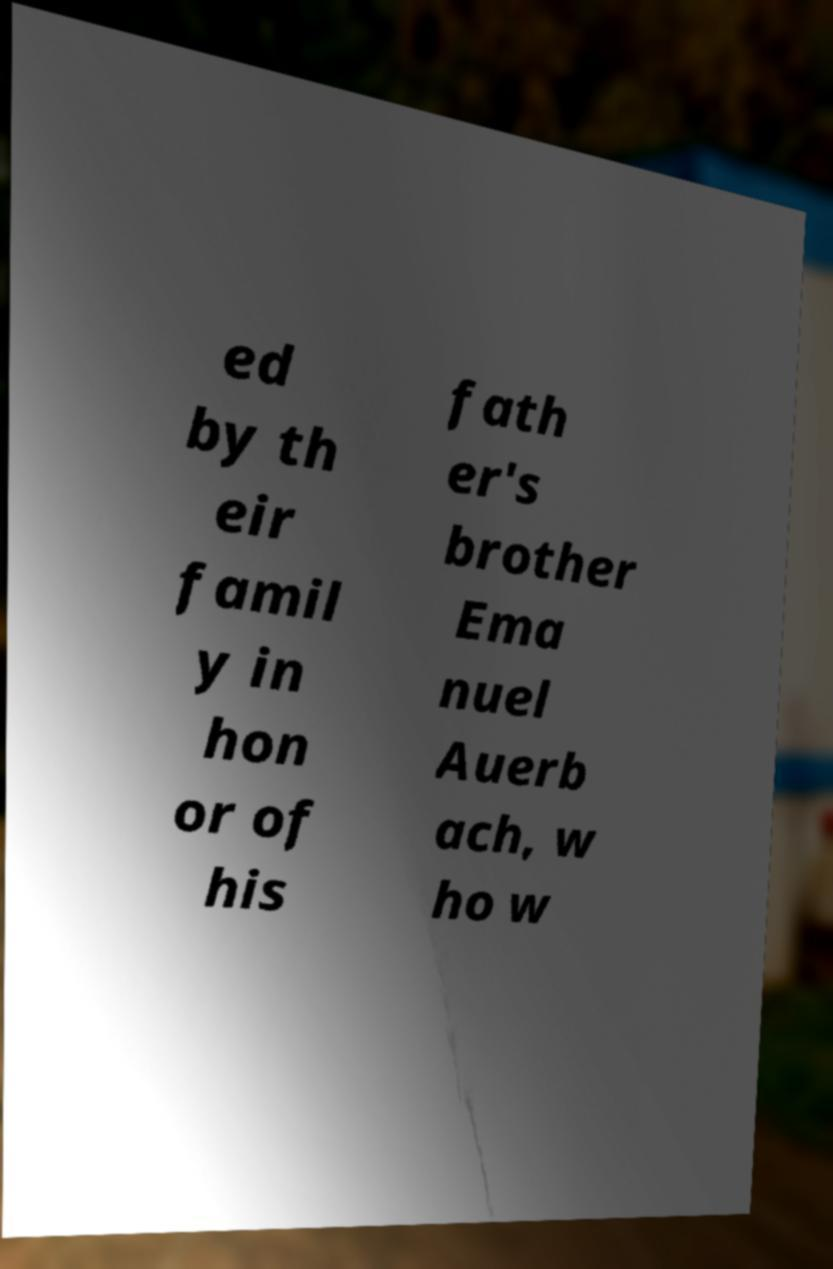What messages or text are displayed in this image? I need them in a readable, typed format. ed by th eir famil y in hon or of his fath er's brother Ema nuel Auerb ach, w ho w 